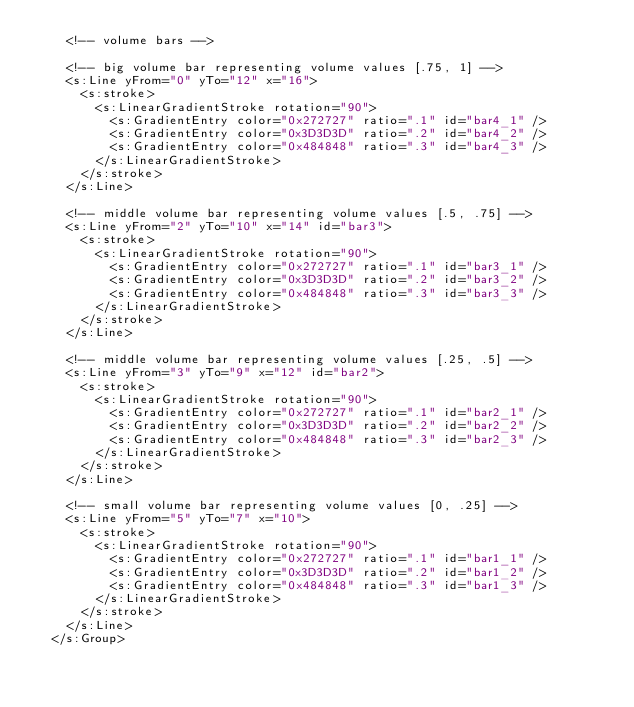<code> <loc_0><loc_0><loc_500><loc_500><_XML_>		<!-- volume bars -->
		
		<!-- big volume bar representing volume values [.75, 1] -->
		<s:Line yFrom="0" yTo="12" x="16">
			<s:stroke>
				<s:LinearGradientStroke rotation="90">
					<s:GradientEntry color="0x272727" ratio=".1" id="bar4_1" />
					<s:GradientEntry color="0x3D3D3D" ratio=".2" id="bar4_2" />
					<s:GradientEntry color="0x484848" ratio=".3" id="bar4_3" />
				</s:LinearGradientStroke>
			</s:stroke>
		</s:Line>
		
		<!-- middle volume bar representing volume values [.5, .75] -->
		<s:Line yFrom="2" yTo="10" x="14" id="bar3">
			<s:stroke>
				<s:LinearGradientStroke rotation="90">
					<s:GradientEntry color="0x272727" ratio=".1" id="bar3_1" />
					<s:GradientEntry color="0x3D3D3D" ratio=".2" id="bar3_2" />
					<s:GradientEntry color="0x484848" ratio=".3" id="bar3_3" />
				</s:LinearGradientStroke>
			</s:stroke>
		</s:Line>
		
		<!-- middle volume bar representing volume values [.25, .5] -->
		<s:Line yFrom="3" yTo="9" x="12" id="bar2">
			<s:stroke>
				<s:LinearGradientStroke rotation="90">
					<s:GradientEntry color="0x272727" ratio=".1" id="bar2_1" />
					<s:GradientEntry color="0x3D3D3D" ratio=".2" id="bar2_2" />
					<s:GradientEntry color="0x484848" ratio=".3" id="bar2_3" />
				</s:LinearGradientStroke>
			</s:stroke>
		</s:Line>
		
		<!-- small volume bar representing volume values [0, .25] -->
		<s:Line yFrom="5" yTo="7" x="10">
			<s:stroke>
				<s:LinearGradientStroke rotation="90">
					<s:GradientEntry color="0x272727" ratio=".1" id="bar1_1" />
					<s:GradientEntry color="0x3D3D3D" ratio=".2" id="bar1_2" />
					<s:GradientEntry color="0x484848" ratio=".3" id="bar1_3" />
				</s:LinearGradientStroke>
			</s:stroke>
		</s:Line>
	</s:Group></code> 